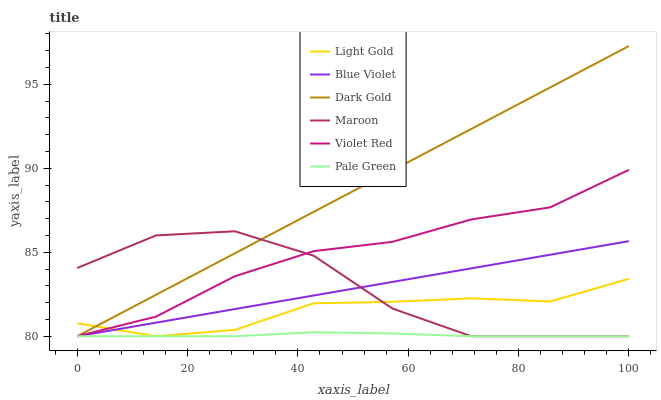Does Pale Green have the minimum area under the curve?
Answer yes or no. Yes. Does Dark Gold have the maximum area under the curve?
Answer yes or no. Yes. Does Maroon have the minimum area under the curve?
Answer yes or no. No. Does Maroon have the maximum area under the curve?
Answer yes or no. No. Is Blue Violet the smoothest?
Answer yes or no. Yes. Is Maroon the roughest?
Answer yes or no. Yes. Is Dark Gold the smoothest?
Answer yes or no. No. Is Dark Gold the roughest?
Answer yes or no. No. Does Dark Gold have the highest value?
Answer yes or no. Yes. Does Maroon have the highest value?
Answer yes or no. No. Does Violet Red intersect Maroon?
Answer yes or no. Yes. Is Violet Red less than Maroon?
Answer yes or no. No. Is Violet Red greater than Maroon?
Answer yes or no. No. 